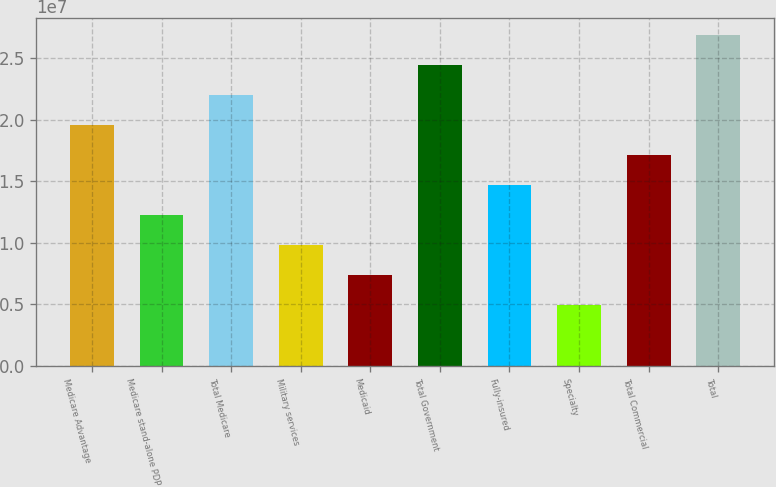Convert chart to OTSL. <chart><loc_0><loc_0><loc_500><loc_500><bar_chart><fcel>Medicare Advantage<fcel>Medicare stand-alone PDP<fcel>Total Medicare<fcel>Military services<fcel>Medicaid<fcel>Total Government<fcel>Fully-insured<fcel>Specialty<fcel>Total Commercial<fcel>Total<nl><fcel>1.95622e+07<fcel>1.2254e+07<fcel>2.19983e+07<fcel>9.81793e+06<fcel>7.38187e+06<fcel>2.44343e+07<fcel>1.46901e+07<fcel>4.9458e+06<fcel>1.71261e+07<fcel>2.68704e+07<nl></chart> 